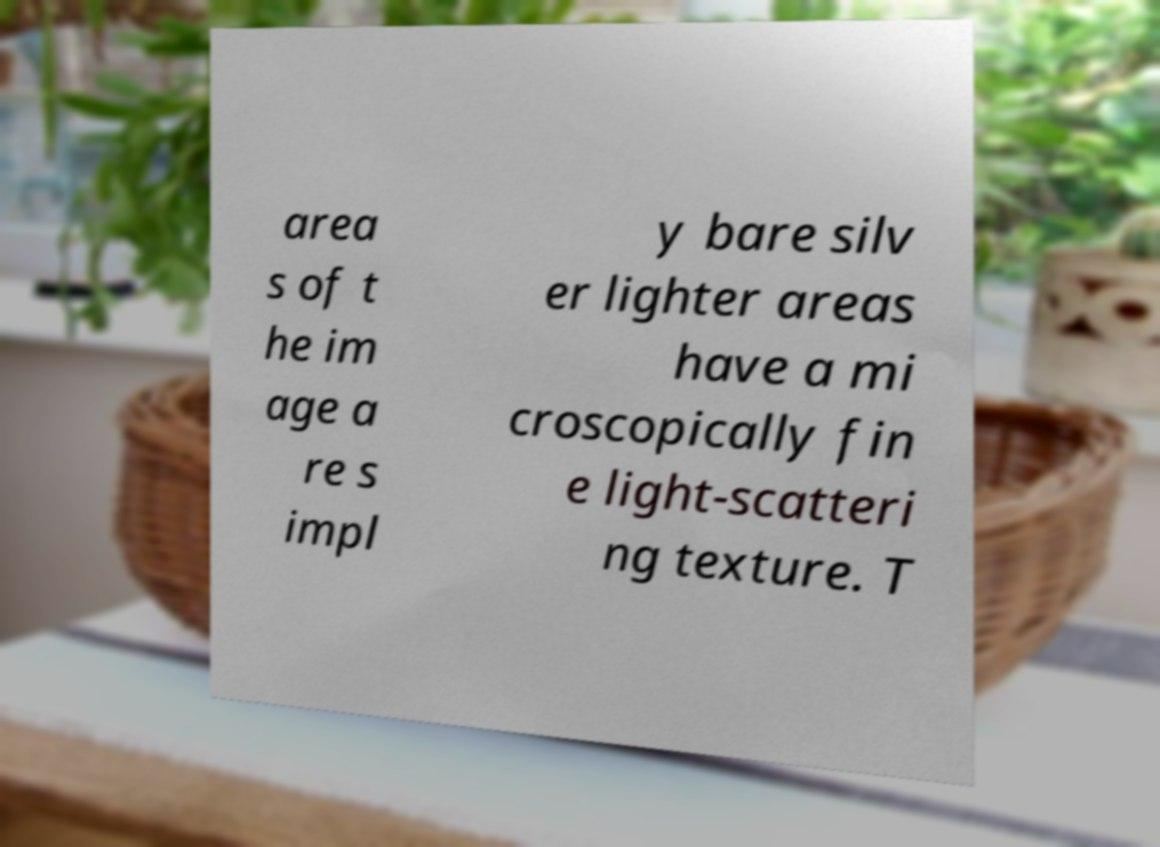What messages or text are displayed in this image? I need them in a readable, typed format. area s of t he im age a re s impl y bare silv er lighter areas have a mi croscopically fin e light-scatteri ng texture. T 